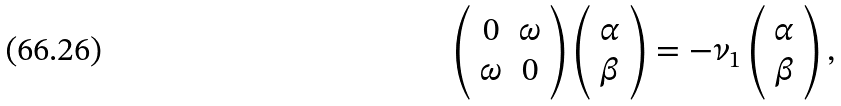<formula> <loc_0><loc_0><loc_500><loc_500>\left ( \begin{array} { c c } 0 & \omega \\ \omega & 0 \end{array} \right ) \left ( \begin{array} { c } \alpha \\ \beta \end{array} \right ) = - \nu _ { 1 } \left ( \begin{array} { c } \alpha \\ \beta \end{array} \right ) ,</formula> 